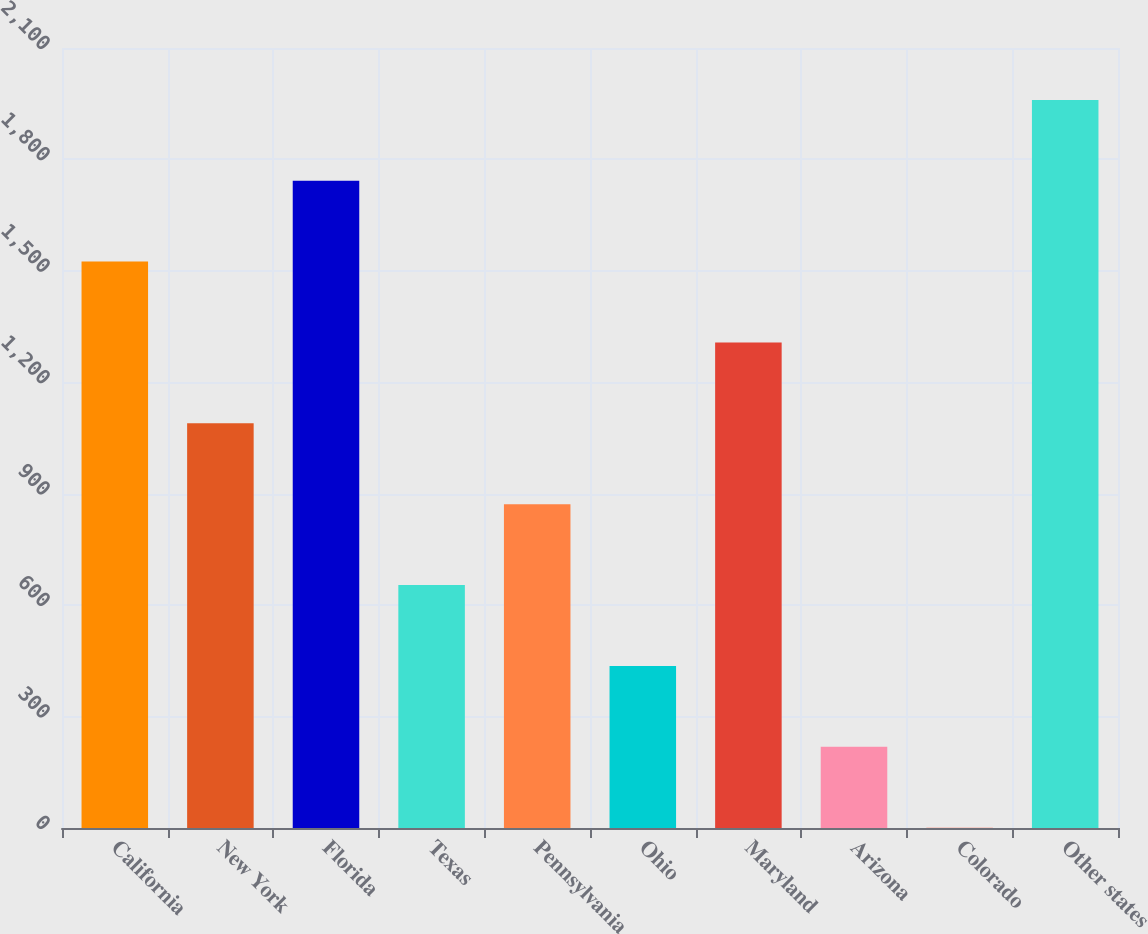Convert chart to OTSL. <chart><loc_0><loc_0><loc_500><loc_500><bar_chart><fcel>California<fcel>New York<fcel>Florida<fcel>Texas<fcel>Pennsylvania<fcel>Ohio<fcel>Maryland<fcel>Arizona<fcel>Colorado<fcel>Other states<nl><fcel>1524.9<fcel>1089.5<fcel>1742.6<fcel>654.1<fcel>871.8<fcel>436.4<fcel>1307.2<fcel>218.7<fcel>1<fcel>1960.3<nl></chart> 